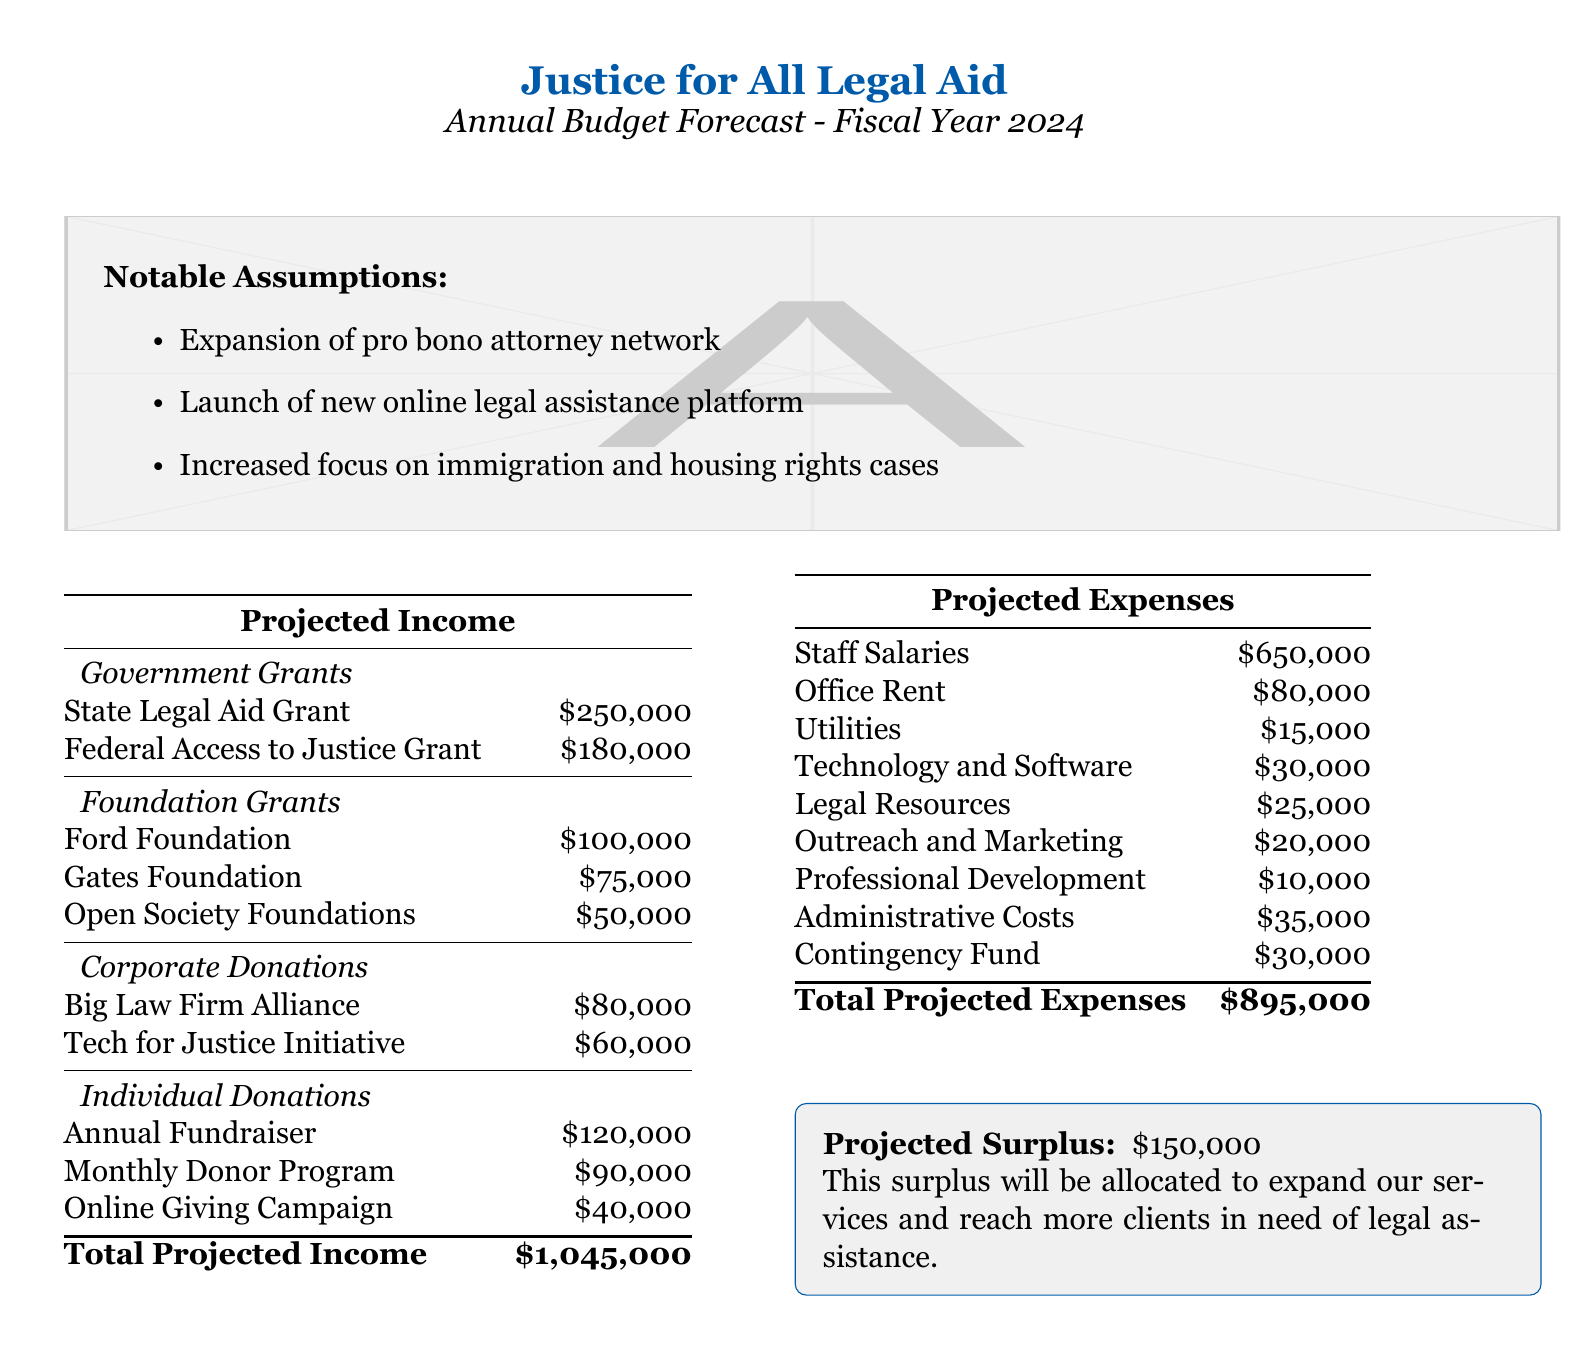what is the total projected income? The total projected income is presented at the bottom of the income table, summing all income sources.
Answer: $1,045,000 what is the amount allocated for staff salaries? The staff salaries amount is listed in the projected expenses table.
Answer: $650,000 which foundation is providing the largest grant? The foundation grants section lists the Ford Foundation as the source of the largest grant.
Answer: Ford Foundation how much is allocated for outreach and marketing? The outreach and marketing expense is specifically stated in the expenses table.
Answer: $20,000 what is the projected surplus? The projected surplus is detailed in the document after the expenses table.
Answer: $150,000 how much funding is coming from government grants? The document specifies the total amount from state and federal government grants in the income section.
Answer: $430,000 what is the total amount set aside for the contingency fund? The contingency fund is a specific line item in the expenses table, indicating its specific allocation.
Answer: $30,000 which corporate donation is contributing the smallest amount? The corporate donations section indicates the Tech for Justice Initiative as the smallest contributor.
Answer: Tech for Justice Initiative what assumptions are listed for the budget forecast? The notable assumptions section outlines the key aspects influencing the budget.
Answer: Expansion of pro bono attorney network, Launch of new online legal assistance platform, Increased focus on immigration and housing rights cases 